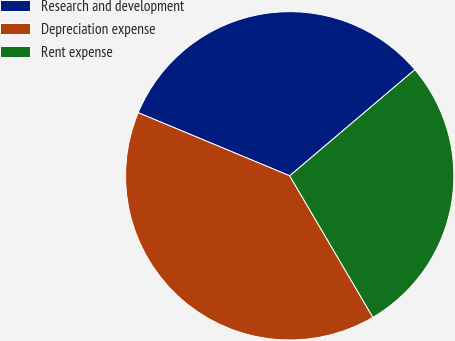Convert chart to OTSL. <chart><loc_0><loc_0><loc_500><loc_500><pie_chart><fcel>Research and development<fcel>Depreciation expense<fcel>Rent expense<nl><fcel>32.52%<fcel>39.74%<fcel>27.74%<nl></chart> 